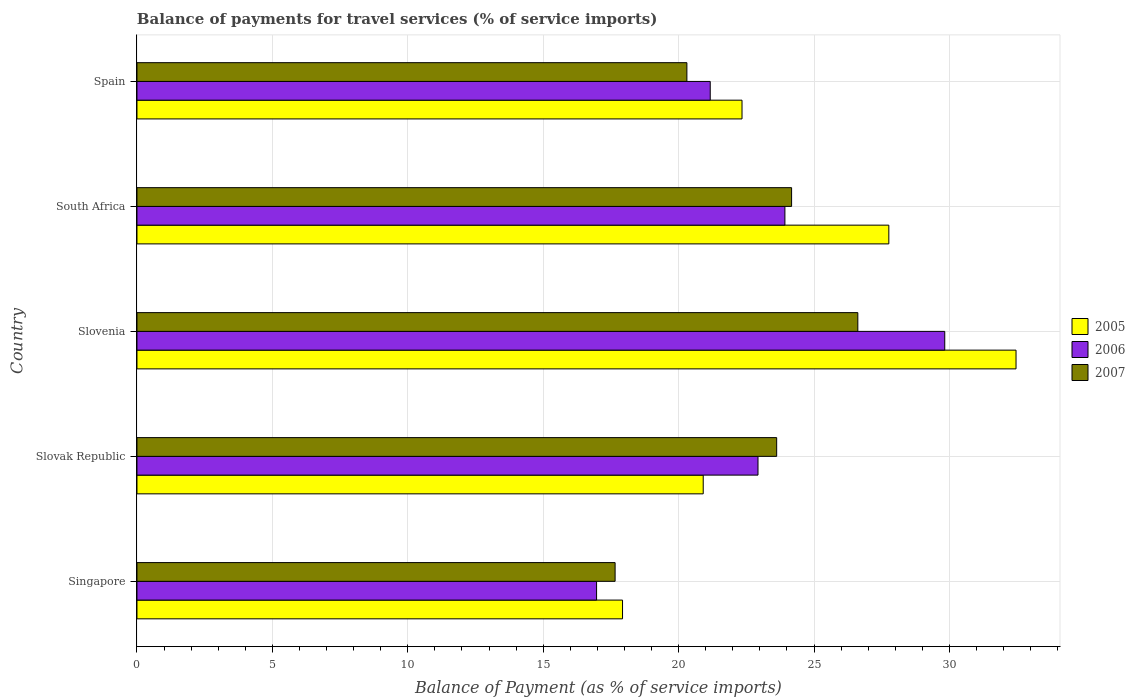How many different coloured bars are there?
Your response must be concise. 3. Are the number of bars per tick equal to the number of legend labels?
Offer a terse response. Yes. Are the number of bars on each tick of the Y-axis equal?
Provide a succinct answer. Yes. What is the label of the 4th group of bars from the top?
Provide a succinct answer. Slovak Republic. In how many cases, is the number of bars for a given country not equal to the number of legend labels?
Your response must be concise. 0. What is the balance of payments for travel services in 2007 in Slovak Republic?
Offer a terse response. 23.62. Across all countries, what is the maximum balance of payments for travel services in 2007?
Make the answer very short. 26.62. Across all countries, what is the minimum balance of payments for travel services in 2005?
Offer a terse response. 17.93. In which country was the balance of payments for travel services in 2007 maximum?
Your answer should be compact. Slovenia. In which country was the balance of payments for travel services in 2005 minimum?
Provide a succinct answer. Singapore. What is the total balance of payments for travel services in 2006 in the graph?
Your answer should be very brief. 114.83. What is the difference between the balance of payments for travel services in 2006 in Singapore and that in Slovak Republic?
Ensure brevity in your answer.  -5.96. What is the difference between the balance of payments for travel services in 2006 in Spain and the balance of payments for travel services in 2005 in Slovenia?
Offer a very short reply. -11.29. What is the average balance of payments for travel services in 2007 per country?
Keep it short and to the point. 22.47. What is the difference between the balance of payments for travel services in 2007 and balance of payments for travel services in 2005 in Slovak Republic?
Offer a very short reply. 2.71. In how many countries, is the balance of payments for travel services in 2007 greater than 10 %?
Offer a terse response. 5. What is the ratio of the balance of payments for travel services in 2007 in Singapore to that in Spain?
Provide a short and direct response. 0.87. Is the balance of payments for travel services in 2006 in Slovak Republic less than that in Spain?
Make the answer very short. No. Is the difference between the balance of payments for travel services in 2007 in Slovak Republic and South Africa greater than the difference between the balance of payments for travel services in 2005 in Slovak Republic and South Africa?
Keep it short and to the point. Yes. What is the difference between the highest and the second highest balance of payments for travel services in 2005?
Your response must be concise. 4.7. What is the difference between the highest and the lowest balance of payments for travel services in 2007?
Give a very brief answer. 8.96. Is the sum of the balance of payments for travel services in 2005 in Singapore and Spain greater than the maximum balance of payments for travel services in 2007 across all countries?
Make the answer very short. Yes. What does the 3rd bar from the top in South Africa represents?
Keep it short and to the point. 2005. How many bars are there?
Provide a succinct answer. 15. What is the difference between two consecutive major ticks on the X-axis?
Give a very brief answer. 5. Does the graph contain any zero values?
Your answer should be compact. No. Does the graph contain grids?
Provide a short and direct response. Yes. Where does the legend appear in the graph?
Ensure brevity in your answer.  Center right. How many legend labels are there?
Your response must be concise. 3. How are the legend labels stacked?
Provide a short and direct response. Vertical. What is the title of the graph?
Your response must be concise. Balance of payments for travel services (% of service imports). Does "1964" appear as one of the legend labels in the graph?
Give a very brief answer. No. What is the label or title of the X-axis?
Ensure brevity in your answer.  Balance of Payment (as % of service imports). What is the label or title of the Y-axis?
Ensure brevity in your answer.  Country. What is the Balance of Payment (as % of service imports) in 2005 in Singapore?
Offer a terse response. 17.93. What is the Balance of Payment (as % of service imports) of 2006 in Singapore?
Your answer should be compact. 16.97. What is the Balance of Payment (as % of service imports) of 2007 in Singapore?
Make the answer very short. 17.66. What is the Balance of Payment (as % of service imports) of 2005 in Slovak Republic?
Your answer should be compact. 20.91. What is the Balance of Payment (as % of service imports) of 2006 in Slovak Republic?
Offer a terse response. 22.93. What is the Balance of Payment (as % of service imports) in 2007 in Slovak Republic?
Keep it short and to the point. 23.62. What is the Balance of Payment (as % of service imports) in 2005 in Slovenia?
Offer a terse response. 32.46. What is the Balance of Payment (as % of service imports) in 2006 in Slovenia?
Offer a terse response. 29.83. What is the Balance of Payment (as % of service imports) of 2007 in Slovenia?
Provide a succinct answer. 26.62. What is the Balance of Payment (as % of service imports) in 2005 in South Africa?
Offer a very short reply. 27.76. What is the Balance of Payment (as % of service imports) in 2006 in South Africa?
Make the answer very short. 23.93. What is the Balance of Payment (as % of service imports) in 2007 in South Africa?
Keep it short and to the point. 24.17. What is the Balance of Payment (as % of service imports) in 2005 in Spain?
Offer a terse response. 22.34. What is the Balance of Payment (as % of service imports) of 2006 in Spain?
Ensure brevity in your answer.  21.17. What is the Balance of Payment (as % of service imports) in 2007 in Spain?
Offer a terse response. 20.31. Across all countries, what is the maximum Balance of Payment (as % of service imports) in 2005?
Your response must be concise. 32.46. Across all countries, what is the maximum Balance of Payment (as % of service imports) in 2006?
Your answer should be very brief. 29.83. Across all countries, what is the maximum Balance of Payment (as % of service imports) of 2007?
Make the answer very short. 26.62. Across all countries, what is the minimum Balance of Payment (as % of service imports) of 2005?
Your response must be concise. 17.93. Across all countries, what is the minimum Balance of Payment (as % of service imports) of 2006?
Ensure brevity in your answer.  16.97. Across all countries, what is the minimum Balance of Payment (as % of service imports) in 2007?
Your answer should be compact. 17.66. What is the total Balance of Payment (as % of service imports) of 2005 in the graph?
Your response must be concise. 121.41. What is the total Balance of Payment (as % of service imports) in 2006 in the graph?
Offer a terse response. 114.83. What is the total Balance of Payment (as % of service imports) of 2007 in the graph?
Offer a terse response. 112.37. What is the difference between the Balance of Payment (as % of service imports) of 2005 in Singapore and that in Slovak Republic?
Provide a short and direct response. -2.98. What is the difference between the Balance of Payment (as % of service imports) in 2006 in Singapore and that in Slovak Republic?
Offer a very short reply. -5.96. What is the difference between the Balance of Payment (as % of service imports) in 2007 in Singapore and that in Slovak Republic?
Give a very brief answer. -5.97. What is the difference between the Balance of Payment (as % of service imports) in 2005 in Singapore and that in Slovenia?
Offer a terse response. -14.53. What is the difference between the Balance of Payment (as % of service imports) in 2006 in Singapore and that in Slovenia?
Provide a succinct answer. -12.86. What is the difference between the Balance of Payment (as % of service imports) in 2007 in Singapore and that in Slovenia?
Your response must be concise. -8.96. What is the difference between the Balance of Payment (as % of service imports) of 2005 in Singapore and that in South Africa?
Give a very brief answer. -9.83. What is the difference between the Balance of Payment (as % of service imports) of 2006 in Singapore and that in South Africa?
Provide a short and direct response. -6.95. What is the difference between the Balance of Payment (as % of service imports) in 2007 in Singapore and that in South Africa?
Your response must be concise. -6.52. What is the difference between the Balance of Payment (as % of service imports) in 2005 in Singapore and that in Spain?
Your response must be concise. -4.41. What is the difference between the Balance of Payment (as % of service imports) in 2006 in Singapore and that in Spain?
Make the answer very short. -4.2. What is the difference between the Balance of Payment (as % of service imports) of 2007 in Singapore and that in Spain?
Provide a succinct answer. -2.65. What is the difference between the Balance of Payment (as % of service imports) of 2005 in Slovak Republic and that in Slovenia?
Make the answer very short. -11.55. What is the difference between the Balance of Payment (as % of service imports) of 2006 in Slovak Republic and that in Slovenia?
Make the answer very short. -6.9. What is the difference between the Balance of Payment (as % of service imports) of 2007 in Slovak Republic and that in Slovenia?
Give a very brief answer. -3. What is the difference between the Balance of Payment (as % of service imports) in 2005 in Slovak Republic and that in South Africa?
Your answer should be compact. -6.85. What is the difference between the Balance of Payment (as % of service imports) in 2006 in Slovak Republic and that in South Africa?
Give a very brief answer. -0.99. What is the difference between the Balance of Payment (as % of service imports) in 2007 in Slovak Republic and that in South Africa?
Provide a short and direct response. -0.55. What is the difference between the Balance of Payment (as % of service imports) in 2005 in Slovak Republic and that in Spain?
Your response must be concise. -1.43. What is the difference between the Balance of Payment (as % of service imports) in 2006 in Slovak Republic and that in Spain?
Offer a very short reply. 1.76. What is the difference between the Balance of Payment (as % of service imports) of 2007 in Slovak Republic and that in Spain?
Your response must be concise. 3.32. What is the difference between the Balance of Payment (as % of service imports) in 2005 in Slovenia and that in South Africa?
Your answer should be compact. 4.7. What is the difference between the Balance of Payment (as % of service imports) in 2006 in Slovenia and that in South Africa?
Offer a terse response. 5.9. What is the difference between the Balance of Payment (as % of service imports) in 2007 in Slovenia and that in South Africa?
Provide a short and direct response. 2.45. What is the difference between the Balance of Payment (as % of service imports) of 2005 in Slovenia and that in Spain?
Your answer should be very brief. 10.12. What is the difference between the Balance of Payment (as % of service imports) in 2006 in Slovenia and that in Spain?
Provide a short and direct response. 8.66. What is the difference between the Balance of Payment (as % of service imports) in 2007 in Slovenia and that in Spain?
Keep it short and to the point. 6.31. What is the difference between the Balance of Payment (as % of service imports) in 2005 in South Africa and that in Spain?
Give a very brief answer. 5.42. What is the difference between the Balance of Payment (as % of service imports) of 2006 in South Africa and that in Spain?
Provide a short and direct response. 2.76. What is the difference between the Balance of Payment (as % of service imports) in 2007 in South Africa and that in Spain?
Give a very brief answer. 3.87. What is the difference between the Balance of Payment (as % of service imports) of 2005 in Singapore and the Balance of Payment (as % of service imports) of 2006 in Slovak Republic?
Give a very brief answer. -5. What is the difference between the Balance of Payment (as % of service imports) in 2005 in Singapore and the Balance of Payment (as % of service imports) in 2007 in Slovak Republic?
Offer a terse response. -5.69. What is the difference between the Balance of Payment (as % of service imports) of 2006 in Singapore and the Balance of Payment (as % of service imports) of 2007 in Slovak Republic?
Keep it short and to the point. -6.65. What is the difference between the Balance of Payment (as % of service imports) in 2005 in Singapore and the Balance of Payment (as % of service imports) in 2006 in Slovenia?
Provide a short and direct response. -11.9. What is the difference between the Balance of Payment (as % of service imports) in 2005 in Singapore and the Balance of Payment (as % of service imports) in 2007 in Slovenia?
Keep it short and to the point. -8.69. What is the difference between the Balance of Payment (as % of service imports) in 2006 in Singapore and the Balance of Payment (as % of service imports) in 2007 in Slovenia?
Your answer should be very brief. -9.65. What is the difference between the Balance of Payment (as % of service imports) of 2005 in Singapore and the Balance of Payment (as % of service imports) of 2006 in South Africa?
Your answer should be very brief. -6. What is the difference between the Balance of Payment (as % of service imports) of 2005 in Singapore and the Balance of Payment (as % of service imports) of 2007 in South Africa?
Ensure brevity in your answer.  -6.24. What is the difference between the Balance of Payment (as % of service imports) in 2006 in Singapore and the Balance of Payment (as % of service imports) in 2007 in South Africa?
Provide a succinct answer. -7.2. What is the difference between the Balance of Payment (as % of service imports) of 2005 in Singapore and the Balance of Payment (as % of service imports) of 2006 in Spain?
Provide a short and direct response. -3.24. What is the difference between the Balance of Payment (as % of service imports) in 2005 in Singapore and the Balance of Payment (as % of service imports) in 2007 in Spain?
Make the answer very short. -2.38. What is the difference between the Balance of Payment (as % of service imports) of 2006 in Singapore and the Balance of Payment (as % of service imports) of 2007 in Spain?
Provide a succinct answer. -3.33. What is the difference between the Balance of Payment (as % of service imports) in 2005 in Slovak Republic and the Balance of Payment (as % of service imports) in 2006 in Slovenia?
Ensure brevity in your answer.  -8.92. What is the difference between the Balance of Payment (as % of service imports) in 2005 in Slovak Republic and the Balance of Payment (as % of service imports) in 2007 in Slovenia?
Your response must be concise. -5.71. What is the difference between the Balance of Payment (as % of service imports) of 2006 in Slovak Republic and the Balance of Payment (as % of service imports) of 2007 in Slovenia?
Provide a succinct answer. -3.69. What is the difference between the Balance of Payment (as % of service imports) of 2005 in Slovak Republic and the Balance of Payment (as % of service imports) of 2006 in South Africa?
Your answer should be very brief. -3.02. What is the difference between the Balance of Payment (as % of service imports) of 2005 in Slovak Republic and the Balance of Payment (as % of service imports) of 2007 in South Africa?
Provide a short and direct response. -3.26. What is the difference between the Balance of Payment (as % of service imports) of 2006 in Slovak Republic and the Balance of Payment (as % of service imports) of 2007 in South Africa?
Offer a terse response. -1.24. What is the difference between the Balance of Payment (as % of service imports) in 2005 in Slovak Republic and the Balance of Payment (as % of service imports) in 2006 in Spain?
Your response must be concise. -0.26. What is the difference between the Balance of Payment (as % of service imports) of 2005 in Slovak Republic and the Balance of Payment (as % of service imports) of 2007 in Spain?
Offer a terse response. 0.6. What is the difference between the Balance of Payment (as % of service imports) of 2006 in Slovak Republic and the Balance of Payment (as % of service imports) of 2007 in Spain?
Provide a short and direct response. 2.63. What is the difference between the Balance of Payment (as % of service imports) of 2005 in Slovenia and the Balance of Payment (as % of service imports) of 2006 in South Africa?
Your answer should be compact. 8.53. What is the difference between the Balance of Payment (as % of service imports) of 2005 in Slovenia and the Balance of Payment (as % of service imports) of 2007 in South Africa?
Your answer should be compact. 8.29. What is the difference between the Balance of Payment (as % of service imports) in 2006 in Slovenia and the Balance of Payment (as % of service imports) in 2007 in South Africa?
Ensure brevity in your answer.  5.66. What is the difference between the Balance of Payment (as % of service imports) of 2005 in Slovenia and the Balance of Payment (as % of service imports) of 2006 in Spain?
Keep it short and to the point. 11.29. What is the difference between the Balance of Payment (as % of service imports) in 2005 in Slovenia and the Balance of Payment (as % of service imports) in 2007 in Spain?
Give a very brief answer. 12.15. What is the difference between the Balance of Payment (as % of service imports) of 2006 in Slovenia and the Balance of Payment (as % of service imports) of 2007 in Spain?
Offer a terse response. 9.52. What is the difference between the Balance of Payment (as % of service imports) of 2005 in South Africa and the Balance of Payment (as % of service imports) of 2006 in Spain?
Give a very brief answer. 6.59. What is the difference between the Balance of Payment (as % of service imports) of 2005 in South Africa and the Balance of Payment (as % of service imports) of 2007 in Spain?
Offer a very short reply. 7.46. What is the difference between the Balance of Payment (as % of service imports) in 2006 in South Africa and the Balance of Payment (as % of service imports) in 2007 in Spain?
Your response must be concise. 3.62. What is the average Balance of Payment (as % of service imports) of 2005 per country?
Provide a short and direct response. 24.28. What is the average Balance of Payment (as % of service imports) in 2006 per country?
Give a very brief answer. 22.97. What is the average Balance of Payment (as % of service imports) in 2007 per country?
Offer a very short reply. 22.48. What is the difference between the Balance of Payment (as % of service imports) in 2005 and Balance of Payment (as % of service imports) in 2006 in Singapore?
Ensure brevity in your answer.  0.96. What is the difference between the Balance of Payment (as % of service imports) in 2005 and Balance of Payment (as % of service imports) in 2007 in Singapore?
Provide a succinct answer. 0.27. What is the difference between the Balance of Payment (as % of service imports) in 2006 and Balance of Payment (as % of service imports) in 2007 in Singapore?
Give a very brief answer. -0.68. What is the difference between the Balance of Payment (as % of service imports) in 2005 and Balance of Payment (as % of service imports) in 2006 in Slovak Republic?
Offer a terse response. -2.02. What is the difference between the Balance of Payment (as % of service imports) of 2005 and Balance of Payment (as % of service imports) of 2007 in Slovak Republic?
Offer a very short reply. -2.71. What is the difference between the Balance of Payment (as % of service imports) of 2006 and Balance of Payment (as % of service imports) of 2007 in Slovak Republic?
Give a very brief answer. -0.69. What is the difference between the Balance of Payment (as % of service imports) in 2005 and Balance of Payment (as % of service imports) in 2006 in Slovenia?
Provide a succinct answer. 2.63. What is the difference between the Balance of Payment (as % of service imports) in 2005 and Balance of Payment (as % of service imports) in 2007 in Slovenia?
Make the answer very short. 5.84. What is the difference between the Balance of Payment (as % of service imports) of 2006 and Balance of Payment (as % of service imports) of 2007 in Slovenia?
Give a very brief answer. 3.21. What is the difference between the Balance of Payment (as % of service imports) in 2005 and Balance of Payment (as % of service imports) in 2006 in South Africa?
Your response must be concise. 3.84. What is the difference between the Balance of Payment (as % of service imports) of 2005 and Balance of Payment (as % of service imports) of 2007 in South Africa?
Provide a short and direct response. 3.59. What is the difference between the Balance of Payment (as % of service imports) in 2006 and Balance of Payment (as % of service imports) in 2007 in South Africa?
Make the answer very short. -0.25. What is the difference between the Balance of Payment (as % of service imports) in 2005 and Balance of Payment (as % of service imports) in 2006 in Spain?
Give a very brief answer. 1.17. What is the difference between the Balance of Payment (as % of service imports) in 2005 and Balance of Payment (as % of service imports) in 2007 in Spain?
Your answer should be very brief. 2.04. What is the difference between the Balance of Payment (as % of service imports) in 2006 and Balance of Payment (as % of service imports) in 2007 in Spain?
Ensure brevity in your answer.  0.86. What is the ratio of the Balance of Payment (as % of service imports) in 2005 in Singapore to that in Slovak Republic?
Your answer should be compact. 0.86. What is the ratio of the Balance of Payment (as % of service imports) of 2006 in Singapore to that in Slovak Republic?
Provide a short and direct response. 0.74. What is the ratio of the Balance of Payment (as % of service imports) of 2007 in Singapore to that in Slovak Republic?
Provide a succinct answer. 0.75. What is the ratio of the Balance of Payment (as % of service imports) of 2005 in Singapore to that in Slovenia?
Offer a terse response. 0.55. What is the ratio of the Balance of Payment (as % of service imports) of 2006 in Singapore to that in Slovenia?
Offer a very short reply. 0.57. What is the ratio of the Balance of Payment (as % of service imports) in 2007 in Singapore to that in Slovenia?
Your response must be concise. 0.66. What is the ratio of the Balance of Payment (as % of service imports) of 2005 in Singapore to that in South Africa?
Keep it short and to the point. 0.65. What is the ratio of the Balance of Payment (as % of service imports) in 2006 in Singapore to that in South Africa?
Offer a terse response. 0.71. What is the ratio of the Balance of Payment (as % of service imports) in 2007 in Singapore to that in South Africa?
Keep it short and to the point. 0.73. What is the ratio of the Balance of Payment (as % of service imports) in 2005 in Singapore to that in Spain?
Your answer should be compact. 0.8. What is the ratio of the Balance of Payment (as % of service imports) in 2006 in Singapore to that in Spain?
Your response must be concise. 0.8. What is the ratio of the Balance of Payment (as % of service imports) of 2007 in Singapore to that in Spain?
Provide a succinct answer. 0.87. What is the ratio of the Balance of Payment (as % of service imports) of 2005 in Slovak Republic to that in Slovenia?
Your response must be concise. 0.64. What is the ratio of the Balance of Payment (as % of service imports) in 2006 in Slovak Republic to that in Slovenia?
Provide a short and direct response. 0.77. What is the ratio of the Balance of Payment (as % of service imports) in 2007 in Slovak Republic to that in Slovenia?
Your answer should be very brief. 0.89. What is the ratio of the Balance of Payment (as % of service imports) of 2005 in Slovak Republic to that in South Africa?
Your answer should be very brief. 0.75. What is the ratio of the Balance of Payment (as % of service imports) of 2006 in Slovak Republic to that in South Africa?
Your answer should be compact. 0.96. What is the ratio of the Balance of Payment (as % of service imports) in 2007 in Slovak Republic to that in South Africa?
Your response must be concise. 0.98. What is the ratio of the Balance of Payment (as % of service imports) in 2005 in Slovak Republic to that in Spain?
Make the answer very short. 0.94. What is the ratio of the Balance of Payment (as % of service imports) of 2006 in Slovak Republic to that in Spain?
Keep it short and to the point. 1.08. What is the ratio of the Balance of Payment (as % of service imports) in 2007 in Slovak Republic to that in Spain?
Your answer should be very brief. 1.16. What is the ratio of the Balance of Payment (as % of service imports) in 2005 in Slovenia to that in South Africa?
Your answer should be compact. 1.17. What is the ratio of the Balance of Payment (as % of service imports) in 2006 in Slovenia to that in South Africa?
Provide a succinct answer. 1.25. What is the ratio of the Balance of Payment (as % of service imports) in 2007 in Slovenia to that in South Africa?
Provide a short and direct response. 1.1. What is the ratio of the Balance of Payment (as % of service imports) of 2005 in Slovenia to that in Spain?
Give a very brief answer. 1.45. What is the ratio of the Balance of Payment (as % of service imports) of 2006 in Slovenia to that in Spain?
Ensure brevity in your answer.  1.41. What is the ratio of the Balance of Payment (as % of service imports) of 2007 in Slovenia to that in Spain?
Make the answer very short. 1.31. What is the ratio of the Balance of Payment (as % of service imports) of 2005 in South Africa to that in Spain?
Give a very brief answer. 1.24. What is the ratio of the Balance of Payment (as % of service imports) in 2006 in South Africa to that in Spain?
Your response must be concise. 1.13. What is the ratio of the Balance of Payment (as % of service imports) in 2007 in South Africa to that in Spain?
Your answer should be compact. 1.19. What is the difference between the highest and the second highest Balance of Payment (as % of service imports) of 2005?
Keep it short and to the point. 4.7. What is the difference between the highest and the second highest Balance of Payment (as % of service imports) of 2006?
Provide a succinct answer. 5.9. What is the difference between the highest and the second highest Balance of Payment (as % of service imports) in 2007?
Offer a very short reply. 2.45. What is the difference between the highest and the lowest Balance of Payment (as % of service imports) of 2005?
Make the answer very short. 14.53. What is the difference between the highest and the lowest Balance of Payment (as % of service imports) in 2006?
Your response must be concise. 12.86. What is the difference between the highest and the lowest Balance of Payment (as % of service imports) in 2007?
Provide a short and direct response. 8.96. 